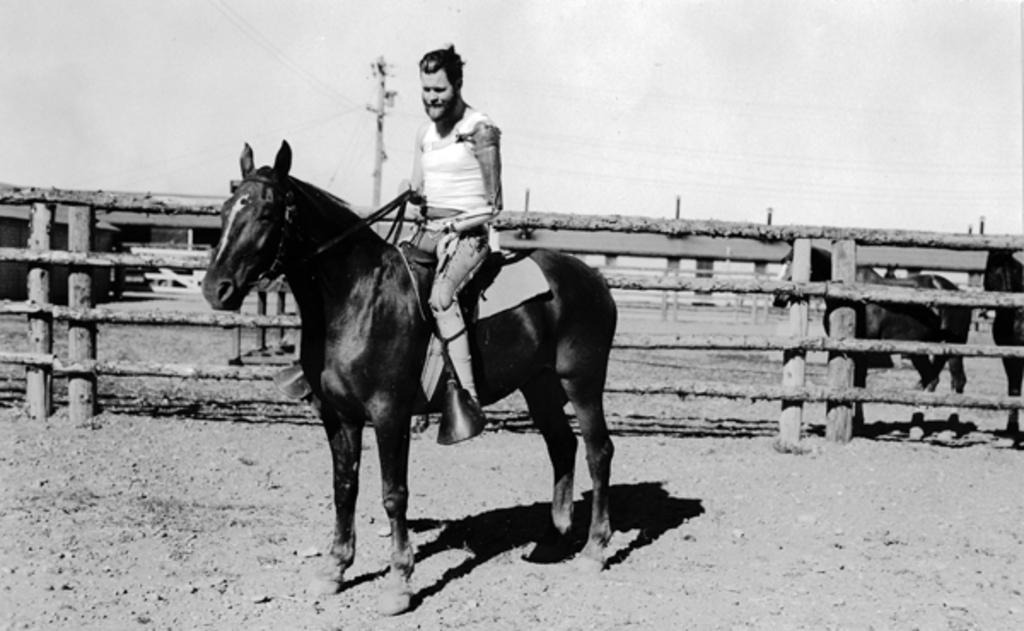Who is present in the image? There is a person in the image. What is the person doing in the image? The person is sitting on a horse. What type of terrain is visible in the image? The ground appears to be sand. What other animal is present in the image? There is a horse in the image. What structures can be seen in the image? There is a fence and a pole in the image. What type of machine is being used by the slave in the image? There is no slave or machine present in the image. Where is the faucet located in the image? There is no faucet present in the image. 